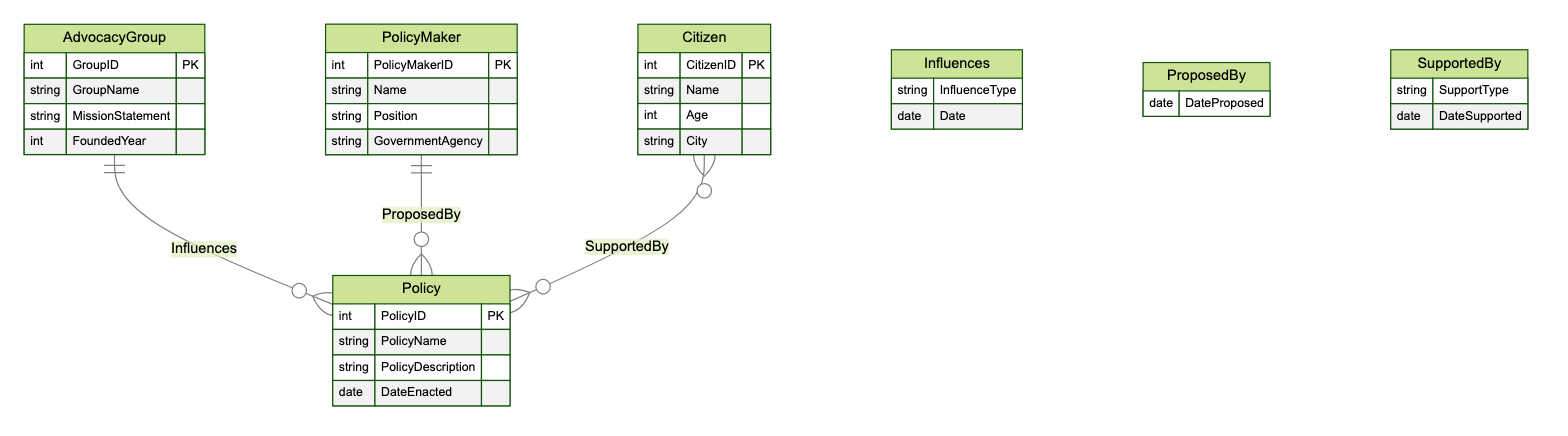What is the primary relationship type between Advocacy Groups and Policies? The primary relationship type is "Influences," which connects the AdvocacyGroup entity to the Policy entity. This relationship is indicated by the label and the connecting line in the diagram.
Answer: Influences How many attributes does the PolicyMaker entity have? The PolicyMaker entity contains four attributes: PolicyMakerID, Name, Position, and GovernmentAgency, which can be counted directly from the entity's definition in the diagram.
Answer: Four What attribute connects the Policy and PolicyMaker entities? The attribute that connects the Policy and PolicyMaker entities is "DateProposed," which is specified in the "ProposedBy" relationship section of the diagram.
Answer: DateProposed What is the relationship type between Citizens and Policies? The relationship type between Citizens and Policies is "SupportedBy," which is indicated in the diagram. This connection shows how citizens support policies.
Answer: SupportedBy How many entities are present in this diagram? The diagram includes four entities: AdvocacyGroup, PolicyMaker, Policy, and Citizen, which can be counted directly from the entities section of the diagram.
Answer: Four What is the minimum number of relationships associated with the Policy entity? The Policy entity has at least two distinct relationships associated with it: "ProposedBy" and "SupportedBy," indicating its interactions with PolicyMaker and Citizen entities.
Answer: Two Which entity has the attribute "FoundedYear"? The entity with the attribute "FoundedYear" is the AdvocacyGroup, which is specifically mentioned in the attributes list of the AdvocacyGroup entity within the diagram.
Answer: AdvocacyGroup What does the "InfluenceType" attribute describe in the context of the diagram? The "InfluenceType" attribute describes the nature of influence that an AdvocacyGroup has on a Policy, as indicated in the relationship "Influences" between these entities.
Answer: Nature of influence What are the attributes of the Citizen entity? The attributes of the Citizen entity are CitizenID, Name, Age, and City, all of which are listed directly in the entity's section of the diagram.
Answer: CitizenID, Name, Age, City 